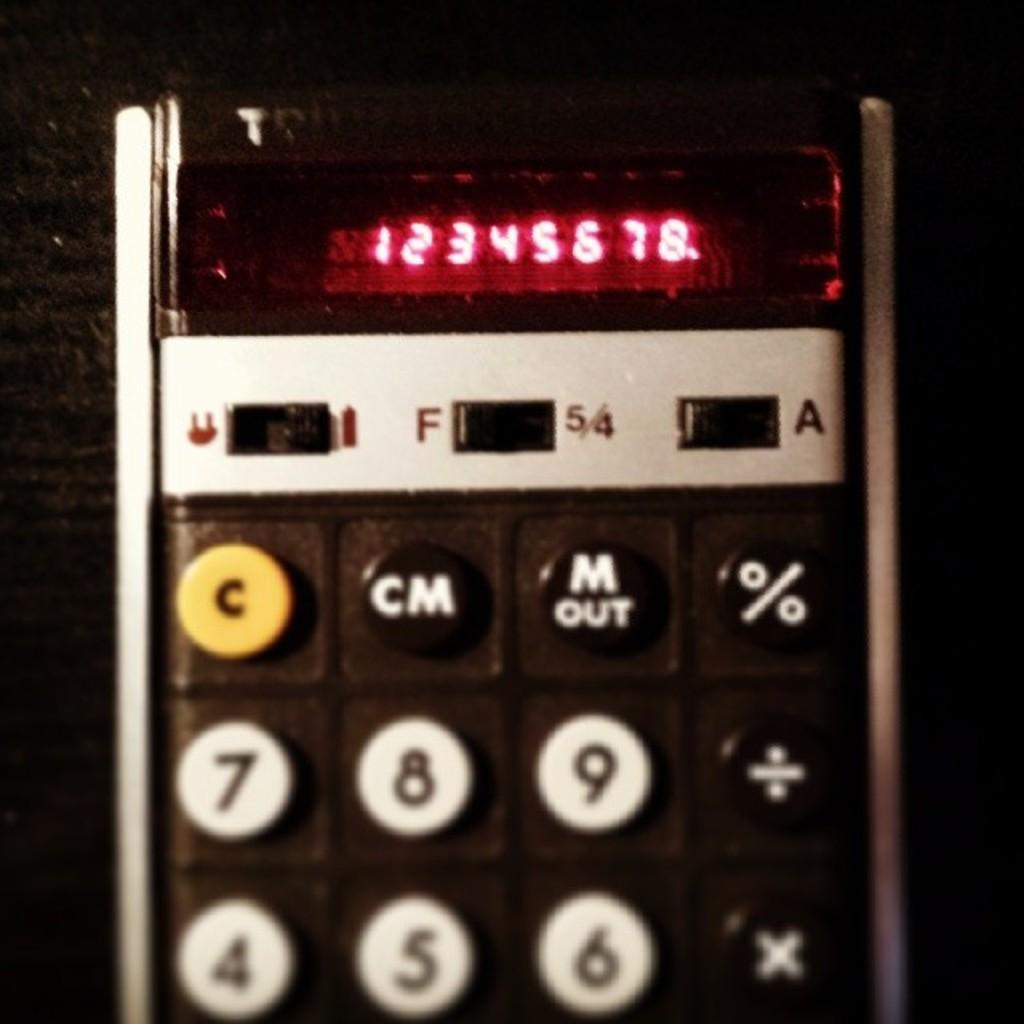Provide a one-sentence caption for the provided image. A calculator that has 12345678 on it with a yellow c button. 